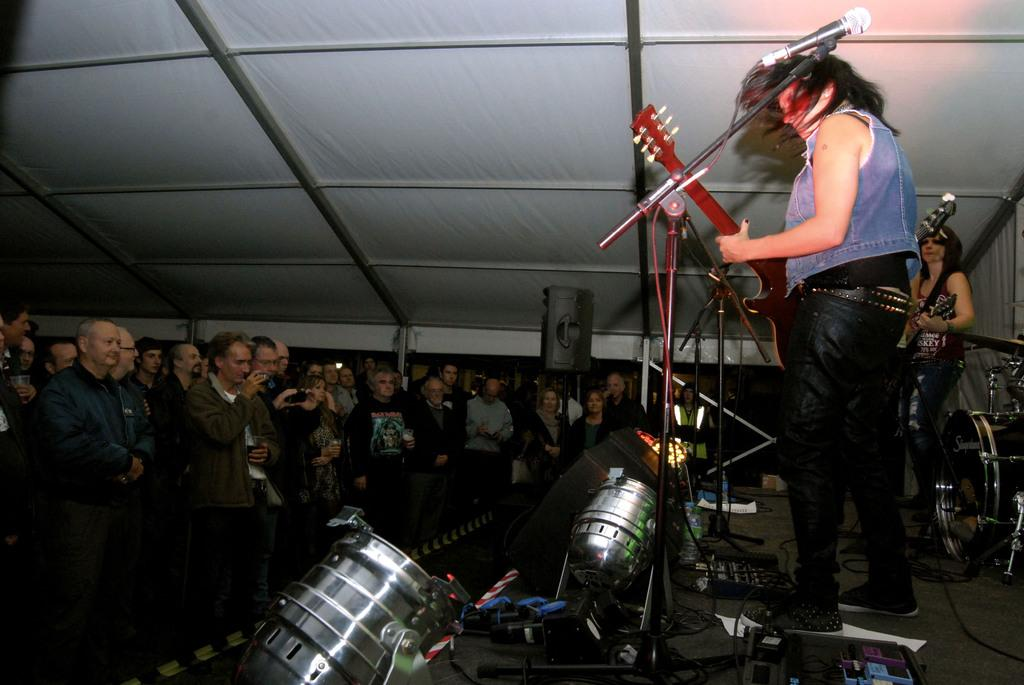What are the two people on the stage doing? The two people on the stage are holding guitars. What equipment is visible on the stage? There are microphones visible on the stage. Are there any other people in the image? Yes, there are people standing nearby. What can be seen in the background of the image? There is a shed visible at the top of the image. What type of income can be seen in the image? There is no reference to income in the image; it features two people on a stage holding guitars, microphones, and nearby people. Can you see any islands in the image? There is no island present in the image. 